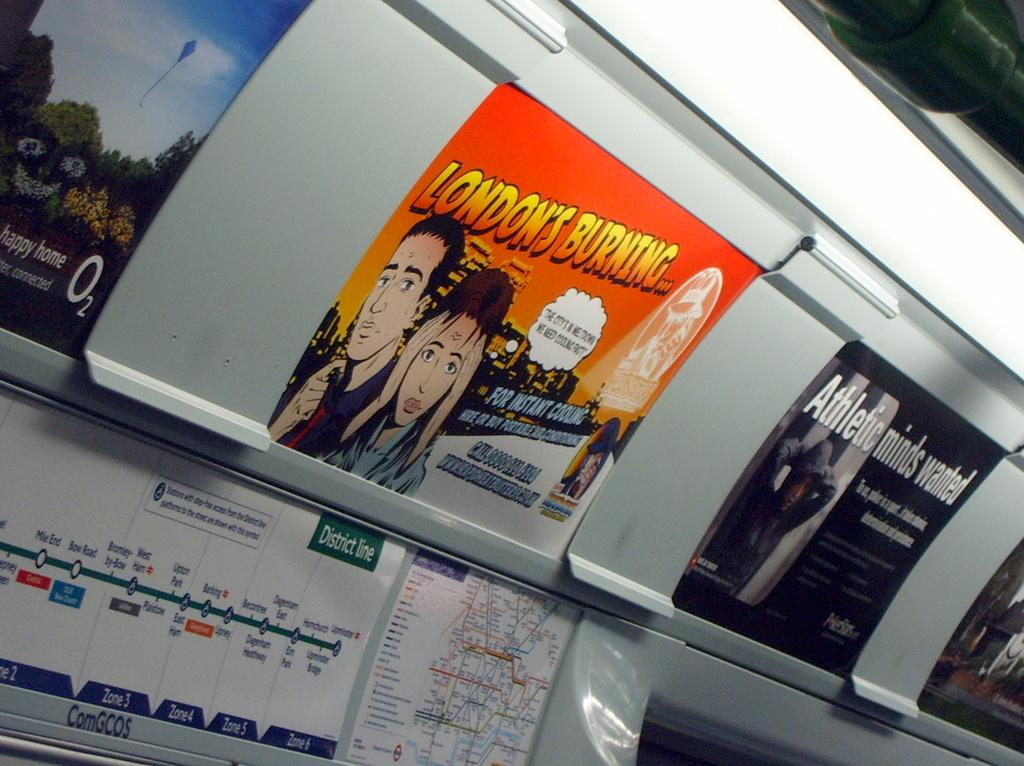Provide a one-sentence caption for the provided image. An advertisement detailing London being burned is placed on a wall. 